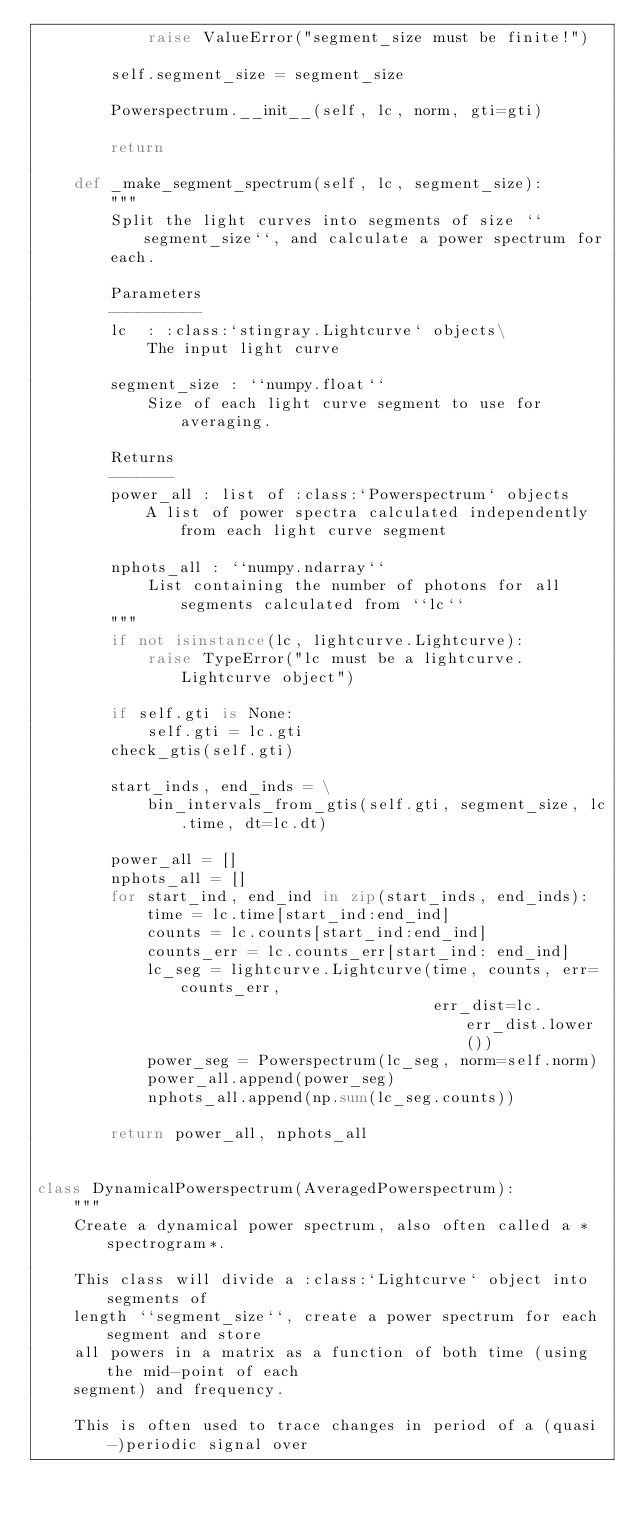Convert code to text. <code><loc_0><loc_0><loc_500><loc_500><_Python_>            raise ValueError("segment_size must be finite!")

        self.segment_size = segment_size

        Powerspectrum.__init__(self, lc, norm, gti=gti)

        return

    def _make_segment_spectrum(self, lc, segment_size):
        """
        Split the light curves into segments of size ``segment_size``, and calculate a power spectrum for
        each.

        Parameters
        ----------
        lc  : :class:`stingray.Lightcurve` objects\
            The input light curve

        segment_size : ``numpy.float``
            Size of each light curve segment to use for averaging.

        Returns
        -------
        power_all : list of :class:`Powerspectrum` objects
            A list of power spectra calculated independently from each light curve segment

        nphots_all : ``numpy.ndarray``
            List containing the number of photons for all segments calculated from ``lc``
        """
        if not isinstance(lc, lightcurve.Lightcurve):
            raise TypeError("lc must be a lightcurve.Lightcurve object")

        if self.gti is None:
            self.gti = lc.gti
        check_gtis(self.gti)

        start_inds, end_inds = \
            bin_intervals_from_gtis(self.gti, segment_size, lc.time, dt=lc.dt)

        power_all = []
        nphots_all = []
        for start_ind, end_ind in zip(start_inds, end_inds):
            time = lc.time[start_ind:end_ind]
            counts = lc.counts[start_ind:end_ind]
            counts_err = lc.counts_err[start_ind: end_ind]
            lc_seg = lightcurve.Lightcurve(time, counts, err=counts_err,
                                           err_dist=lc.err_dist.lower())
            power_seg = Powerspectrum(lc_seg, norm=self.norm)
            power_all.append(power_seg)
            nphots_all.append(np.sum(lc_seg.counts))

        return power_all, nphots_all


class DynamicalPowerspectrum(AveragedPowerspectrum):
    """
    Create a dynamical power spectrum, also often called a *spectrogram*.

    This class will divide a :class:`Lightcurve` object into segments of
    length ``segment_size``, create a power spectrum for each segment and store
    all powers in a matrix as a function of both time (using the mid-point of each
    segment) and frequency.

    This is often used to trace changes in period of a (quasi-)periodic signal over</code> 